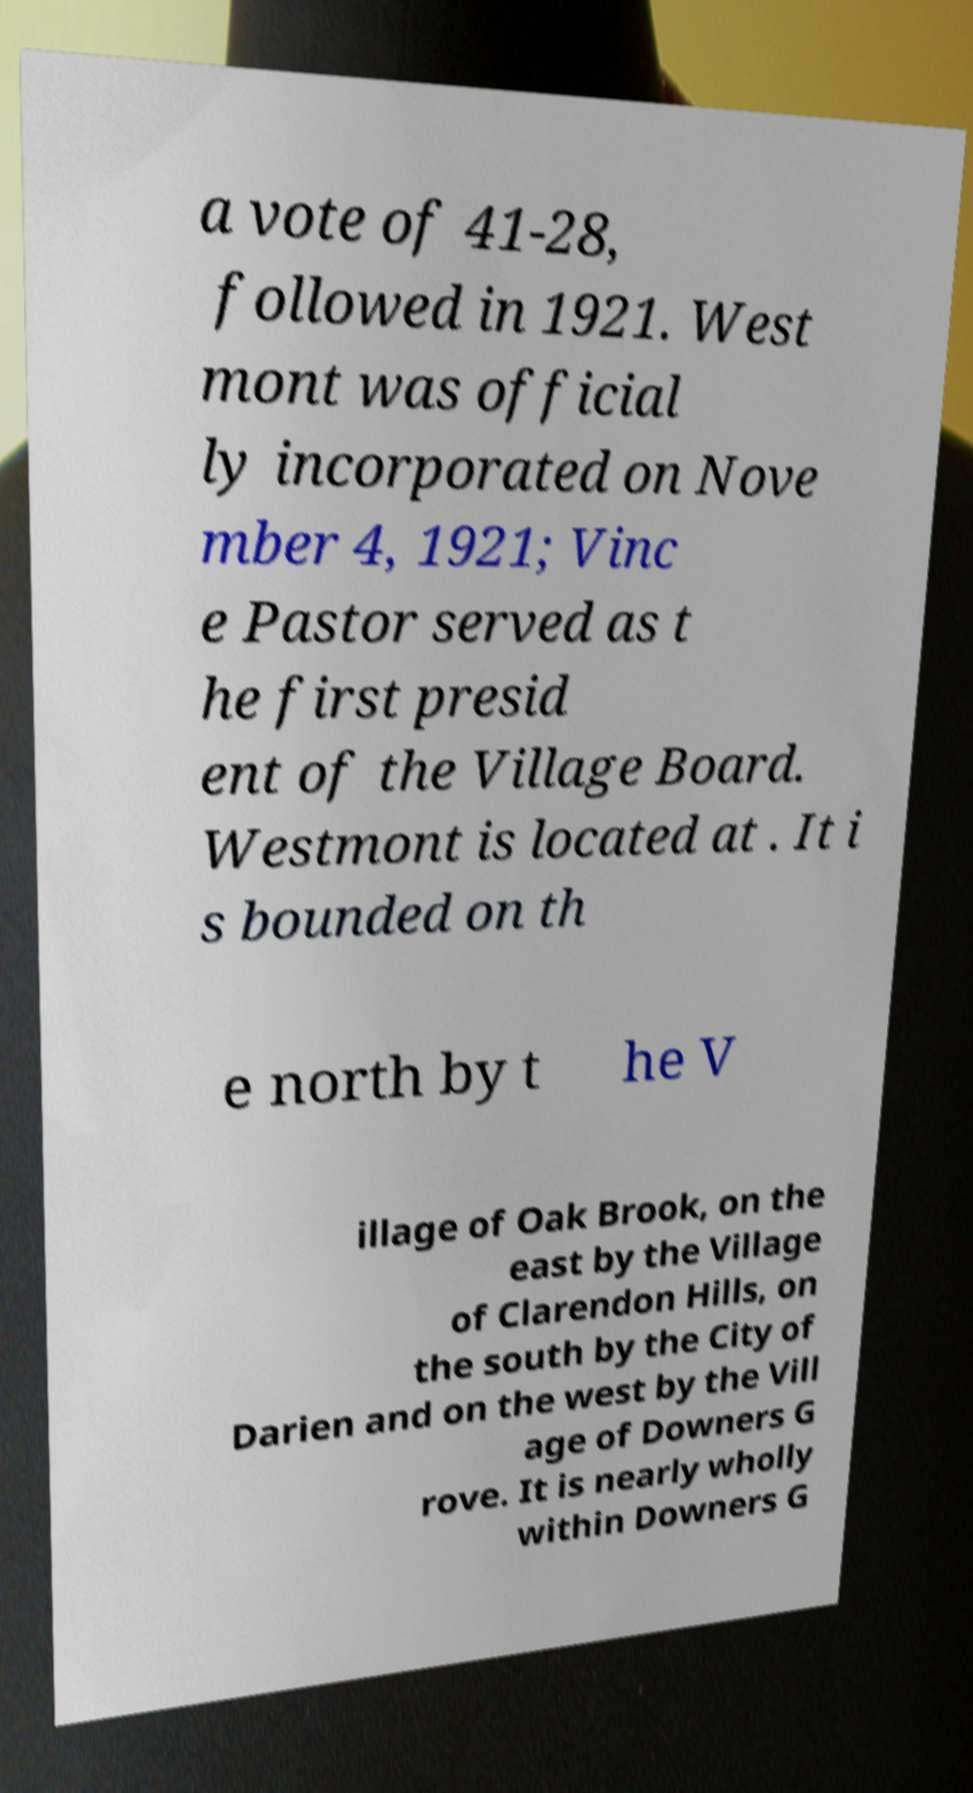Please identify and transcribe the text found in this image. a vote of 41-28, followed in 1921. West mont was official ly incorporated on Nove mber 4, 1921; Vinc e Pastor served as t he first presid ent of the Village Board. Westmont is located at . It i s bounded on th e north by t he V illage of Oak Brook, on the east by the Village of Clarendon Hills, on the south by the City of Darien and on the west by the Vill age of Downers G rove. It is nearly wholly within Downers G 